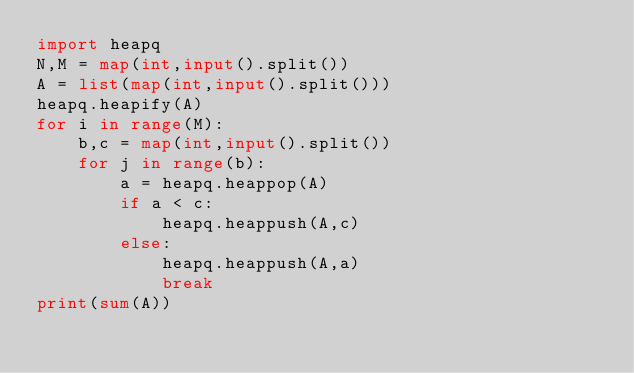Convert code to text. <code><loc_0><loc_0><loc_500><loc_500><_Python_>import heapq
N,M = map(int,input().split())
A = list(map(int,input().split()))
heapq.heapify(A)
for i in range(M):
    b,c = map(int,input().split())
    for j in range(b):
        a = heapq.heappop(A)
        if a < c:
            heapq.heappush(A,c)
        else:
            heapq.heappush(A,a)
            break
print(sum(A))</code> 